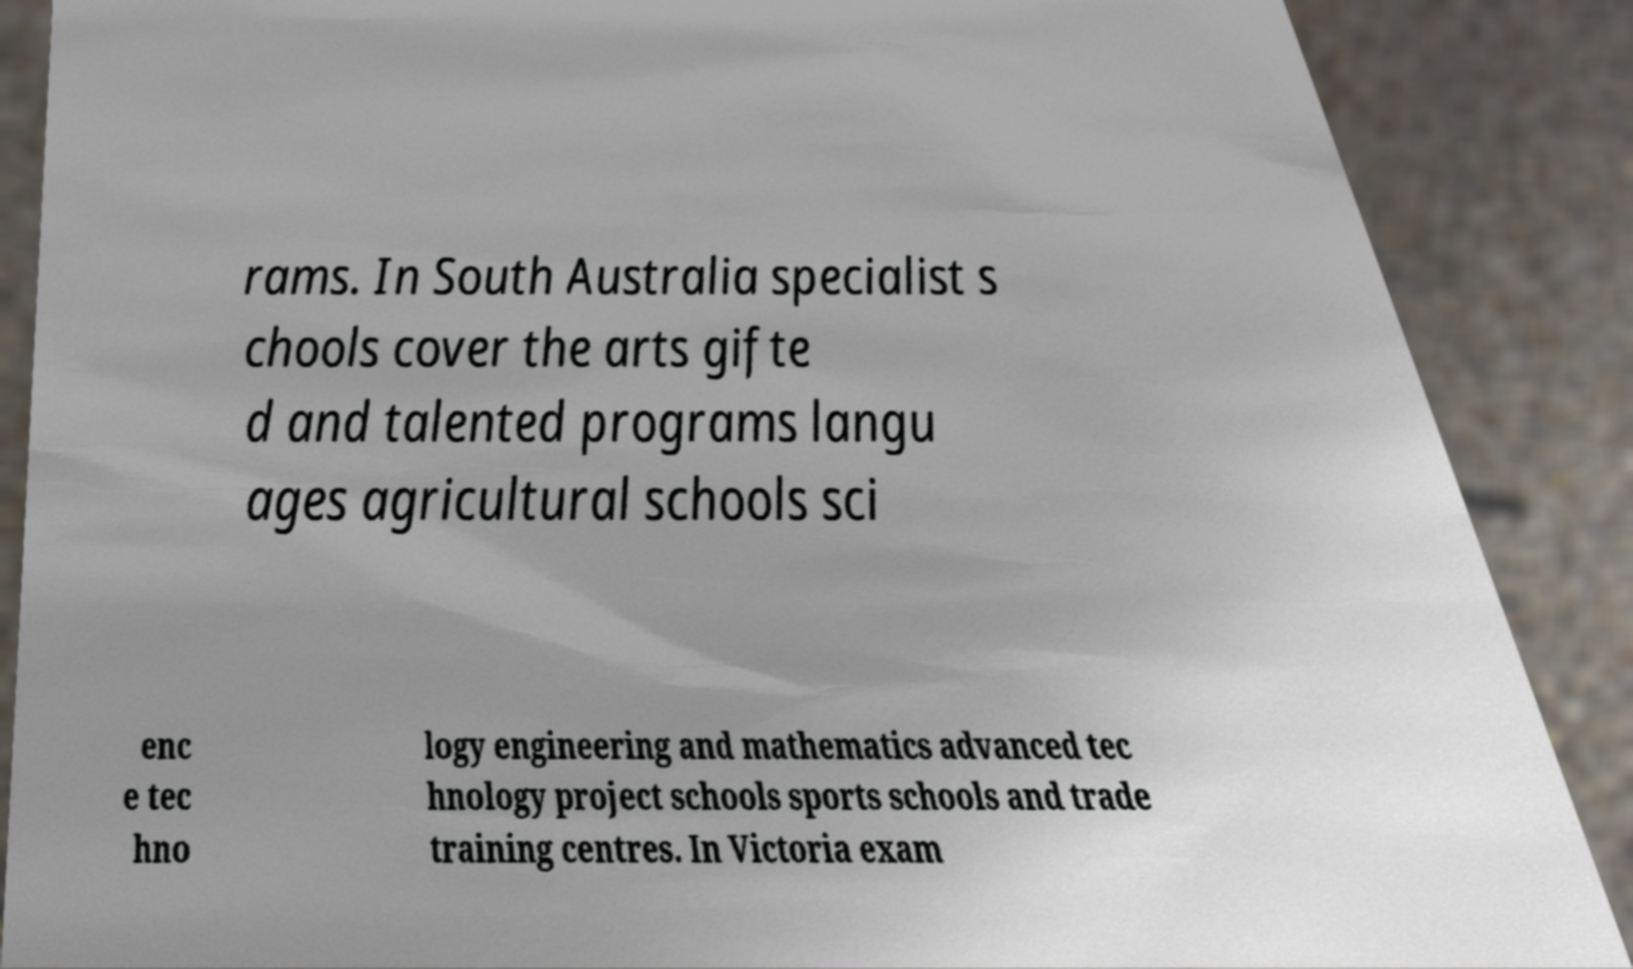Can you accurately transcribe the text from the provided image for me? rams. In South Australia specialist s chools cover the arts gifte d and talented programs langu ages agricultural schools sci enc e tec hno logy engineering and mathematics advanced tec hnology project schools sports schools and trade training centres. In Victoria exam 